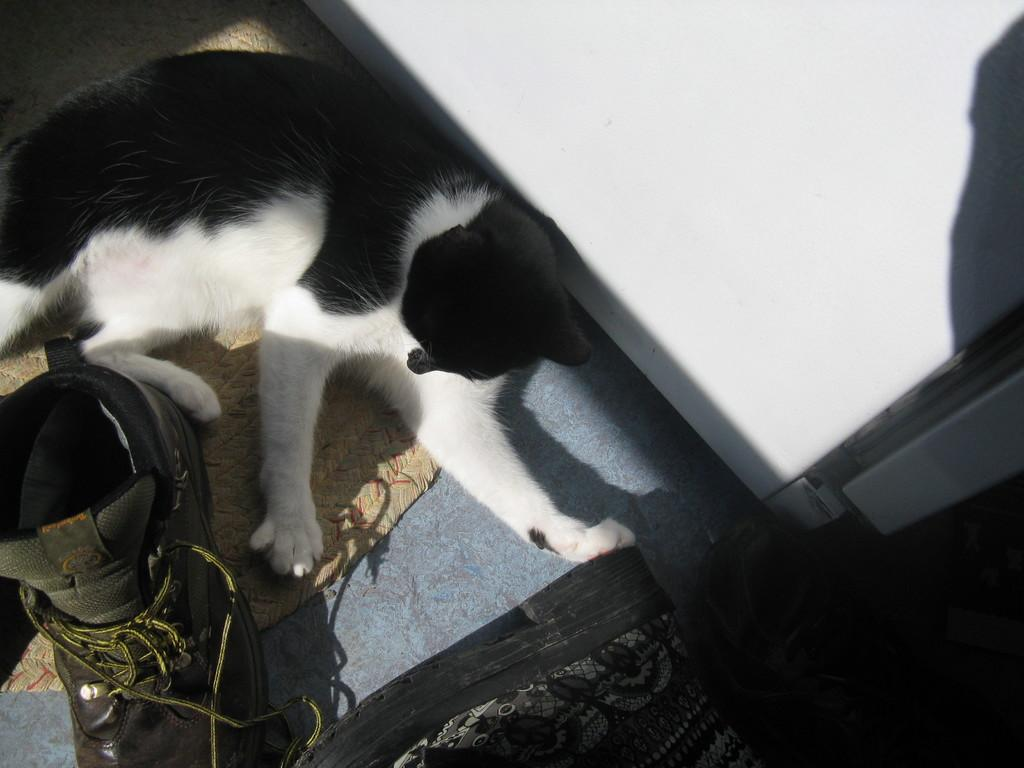What type of creature is present in the image? There is an animal in the image. What color scheme is used for the animal? The animal is in black and white color. What other object can be seen in the image? There is a shoe visible in the image. What is the overall color pattern of the image? There are white and black color objects in the image. How does the animal use its memory to solve a problem in the image? The image does not depict the animal using its memory or solving any problems. 